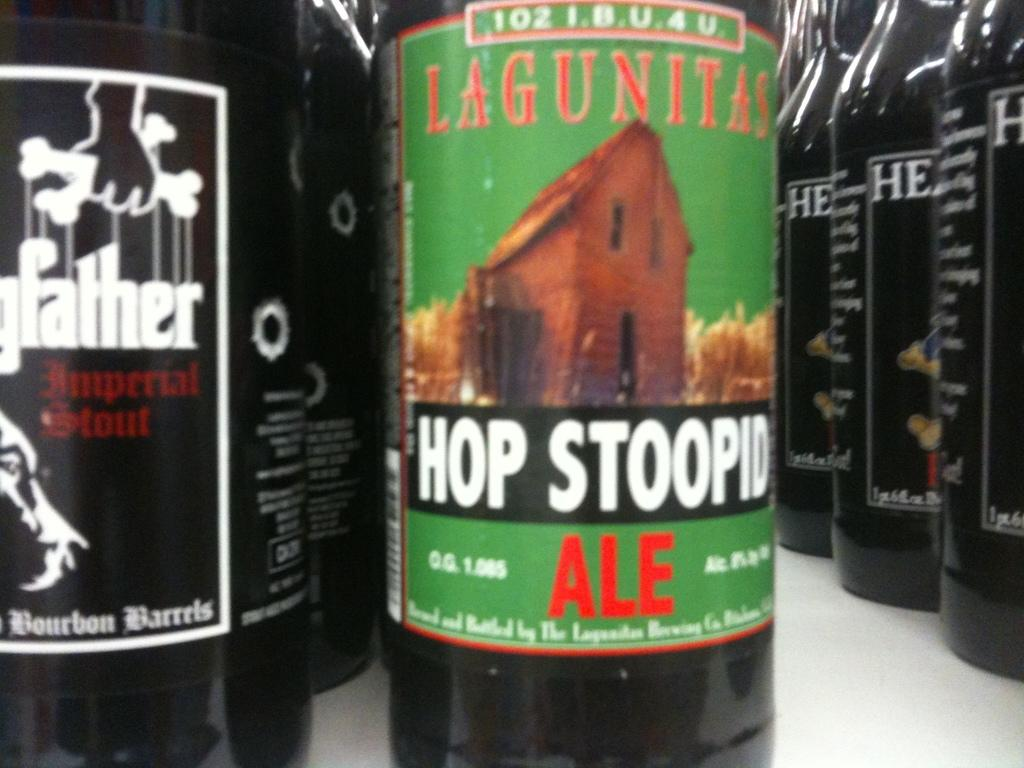<image>
Present a compact description of the photo's key features. Some bottles of beer, one has a green label and Hop Stoopid written on it. 